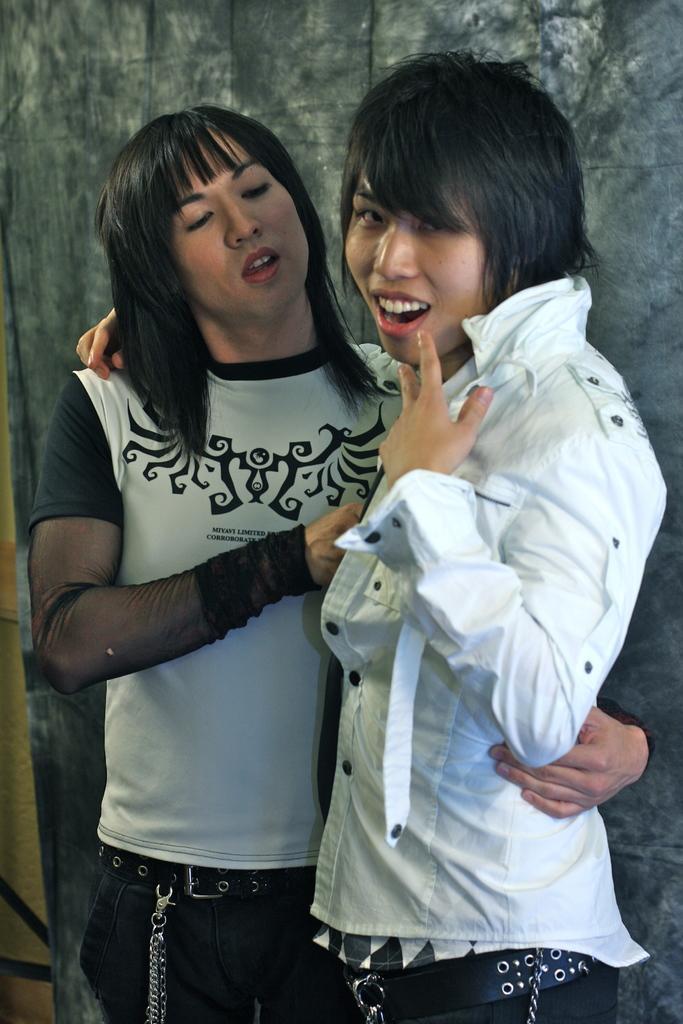In one or two sentences, can you explain what this image depicts? In this image we can see two people. In the background, we can see the wall. One person is wearing a white color shirt and black pant. The other one is wearing a black and white top and black pant. 